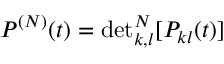<formula> <loc_0><loc_0><loc_500><loc_500>P ^ { ( N ) } ( t ) = d e t _ { k , l } ^ { N } [ P _ { k l } ( t ) ]</formula> 